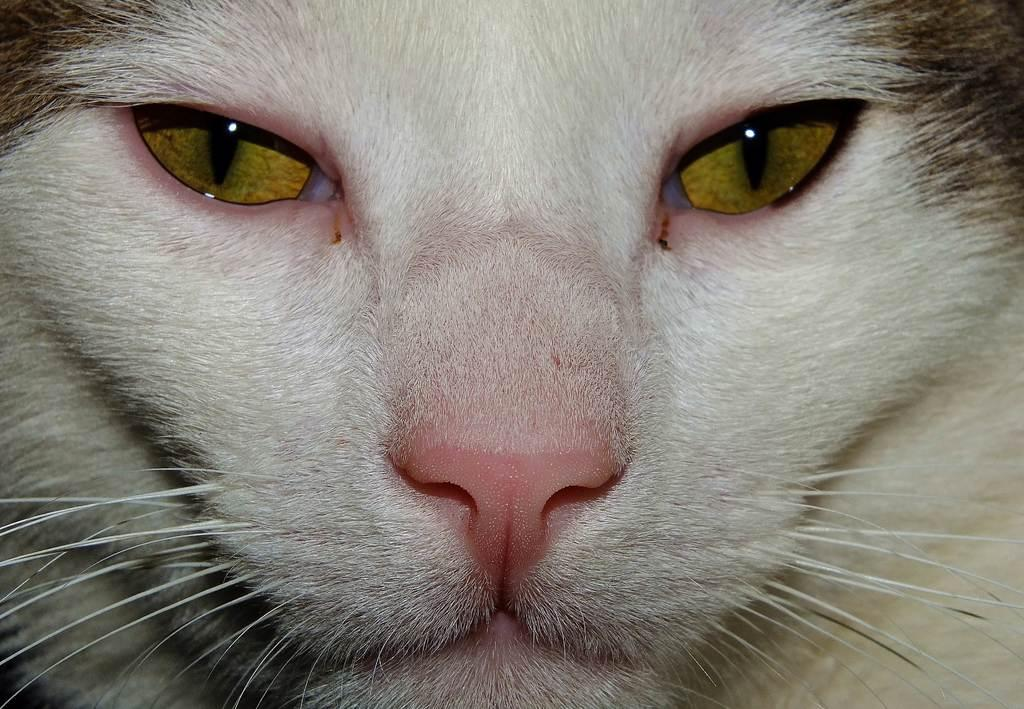What type of animal is in the image? There is a cat in the image. Can you describe the color of the cat? The cat is black and white in color. How does the cat increase its size in the image? The cat does not increase its size in the image; it remains the same size throughout the picture. 